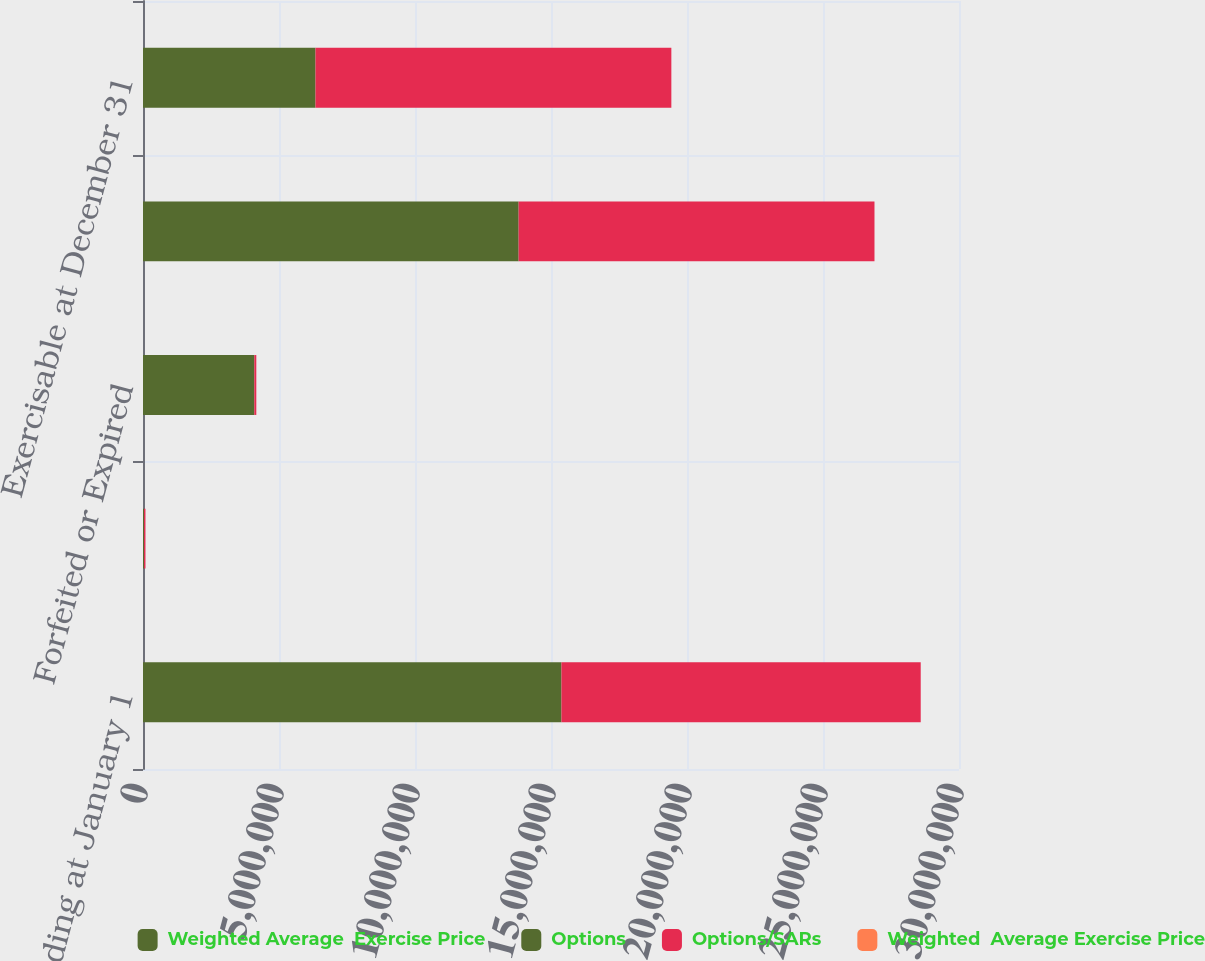Convert chart to OTSL. <chart><loc_0><loc_0><loc_500><loc_500><stacked_bar_chart><ecel><fcel>Outstanding at January 1<fcel>Exercised<fcel>Forfeited or Expired<fcel>Outstanding at December 31<fcel>Exercisable at December 31<nl><fcel>Weighted Average  Exercise Price<fcel>1.53843e+07<fcel>38720<fcel>4.09203e+06<fcel>1.38098e+07<fcel>6.34182e+06<nl><fcel>Options<fcel>13.99<fcel>4.56<fcel>21.8<fcel>10.31<fcel>14.55<nl><fcel>Options/SARs<fcel>1.32084e+07<fcel>51751<fcel>73727<fcel>1.30829e+07<fcel>1.30829e+07<nl><fcel>Weighted  Average Exercise Price<fcel>5.66<fcel>5<fcel>6.52<fcel>5.66<fcel>5.66<nl></chart> 